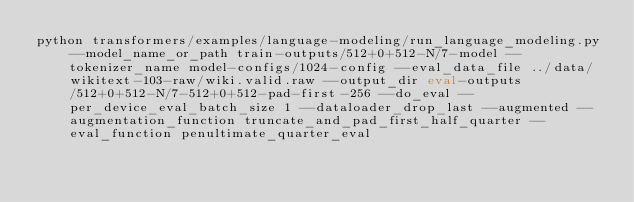Convert code to text. <code><loc_0><loc_0><loc_500><loc_500><_Bash_>python transformers/examples/language-modeling/run_language_modeling.py --model_name_or_path train-outputs/512+0+512-N/7-model --tokenizer_name model-configs/1024-config --eval_data_file ../data/wikitext-103-raw/wiki.valid.raw --output_dir eval-outputs/512+0+512-N/7-512+0+512-pad-first-256 --do_eval --per_device_eval_batch_size 1 --dataloader_drop_last --augmented --augmentation_function truncate_and_pad_first_half_quarter --eval_function penultimate_quarter_eval</code> 